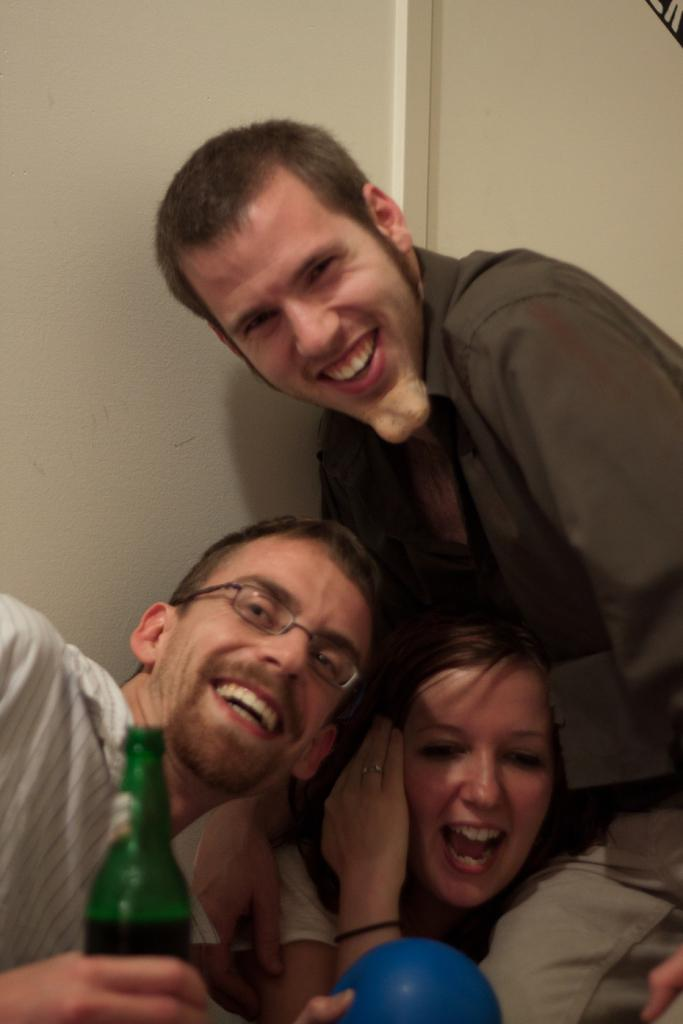How many people are on the left side of the image? There are three persons on the left side of the image. What is one person holding in the image? One person is holding a bottle. Can you describe the expression of the person holding the bottle? The person holding the bottle is smiling. What can be seen in the background of the image? There is a wall in the background of the image. What is the price of the snail on the wall in the image? There is no snail present in the image, so it is not possible to determine its price. 